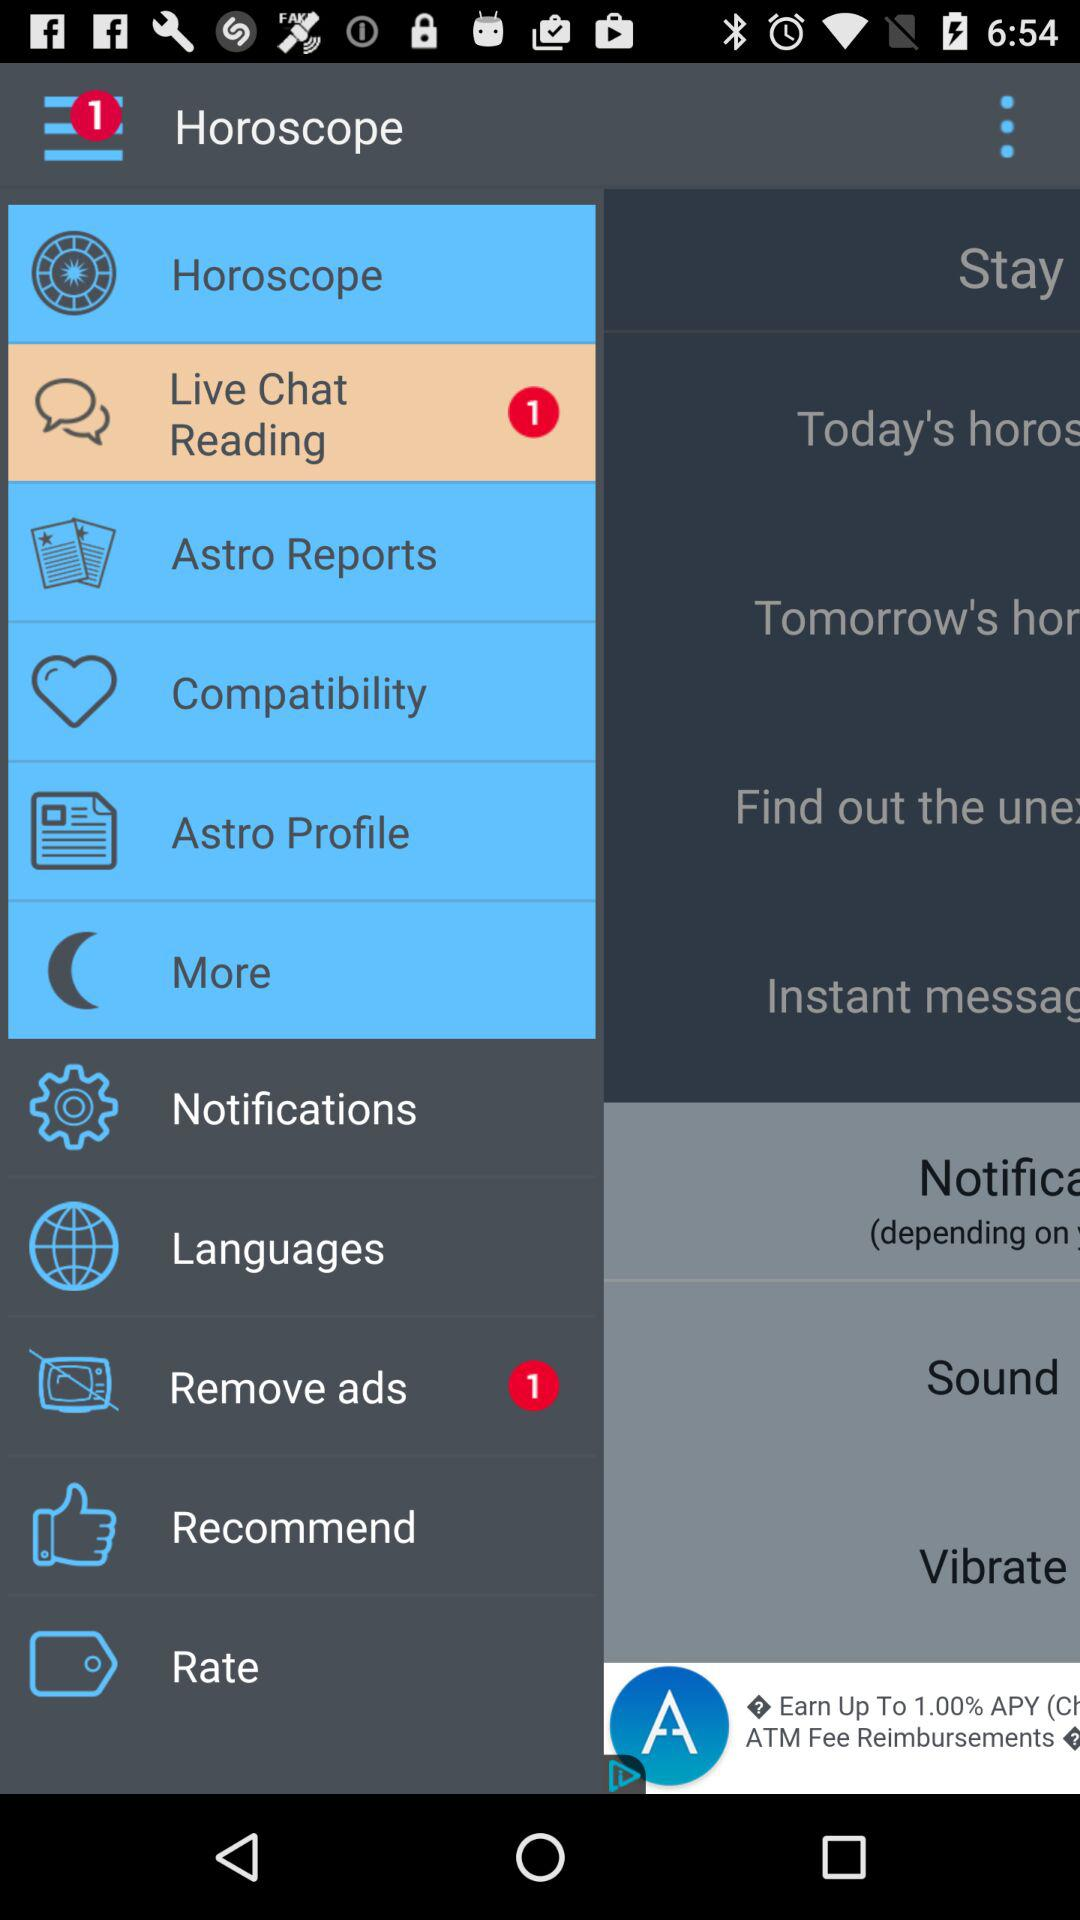What is the number of unread chats in "Live Chat Reading"? The number of unread chats is 1. 